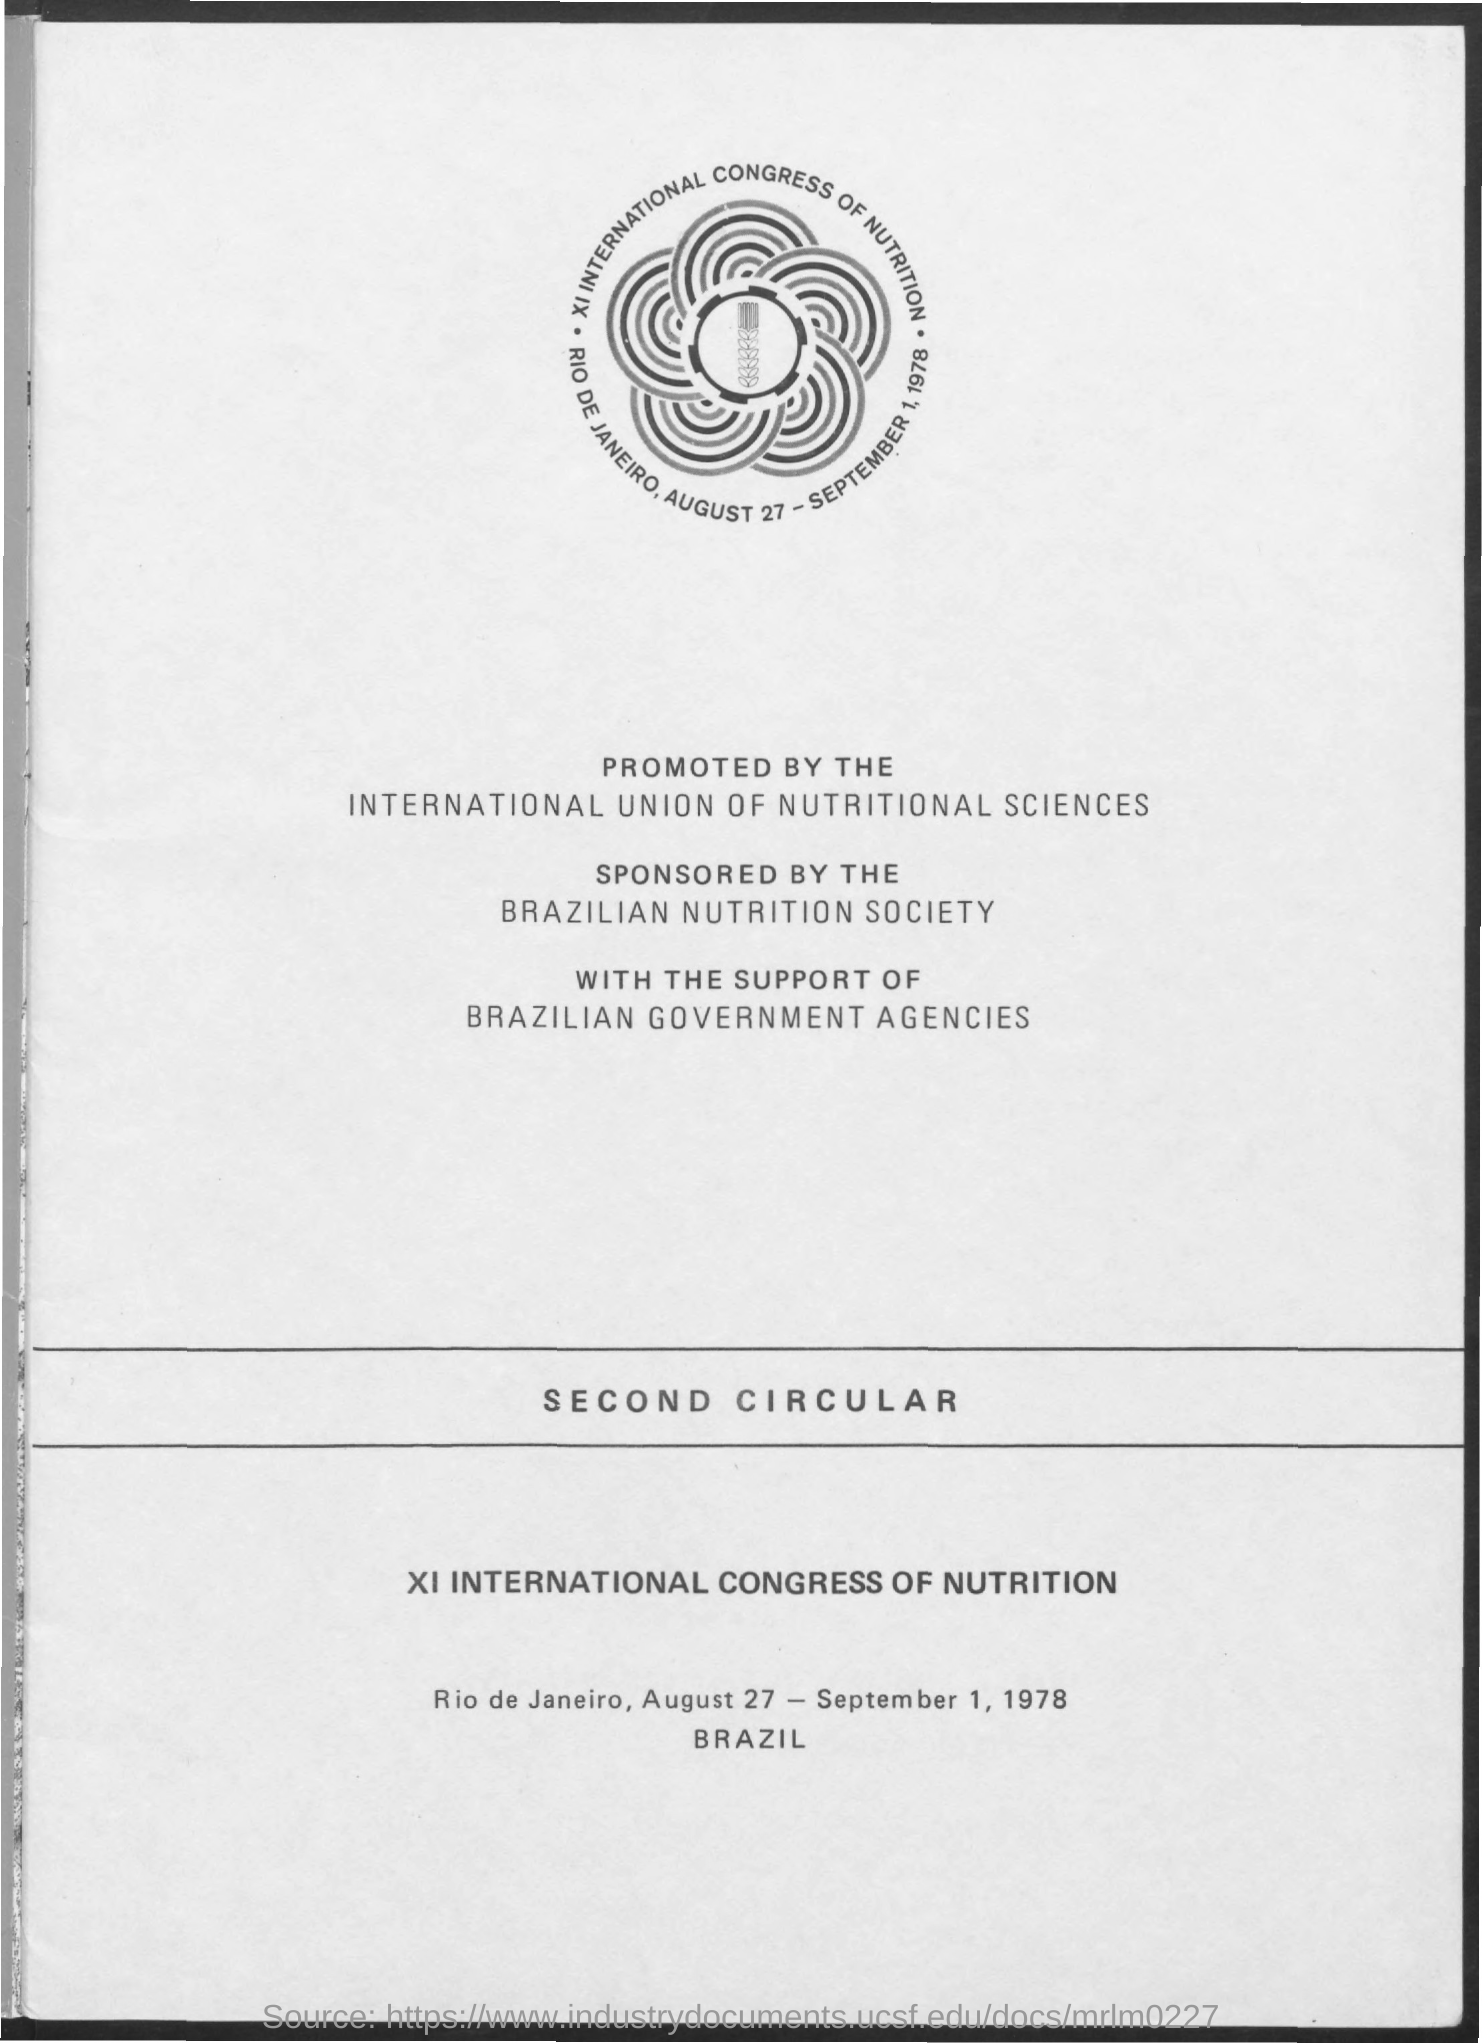Mention a couple of crucial points in this snapshot. Rio de Janeiro is located in the country of Brazil. 